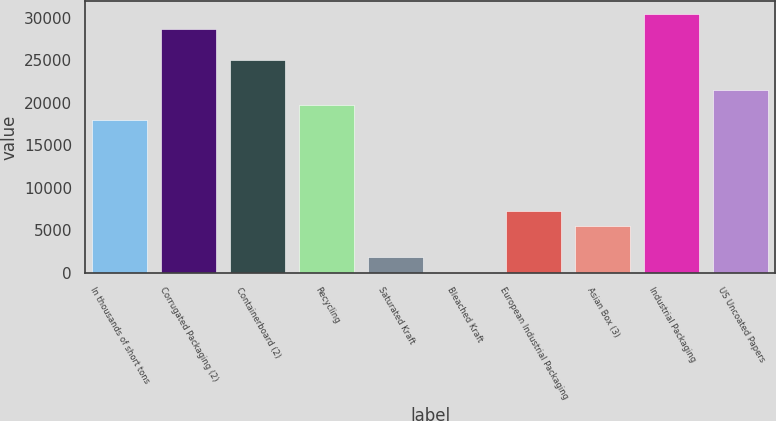Convert chart. <chart><loc_0><loc_0><loc_500><loc_500><bar_chart><fcel>In thousands of short tons<fcel>Corrugated Packaging (2)<fcel>Containerboard (2)<fcel>Recycling<fcel>Saturated Kraft<fcel>Bleached Kraft<fcel>European Industrial Packaging<fcel>Asian Box (3)<fcel>Industrial Packaging<fcel>US Uncoated Papers<nl><fcel>17957<fcel>28662.8<fcel>25094.2<fcel>19741.3<fcel>1898.3<fcel>114<fcel>7251.2<fcel>5466.9<fcel>30447.1<fcel>21525.6<nl></chart> 